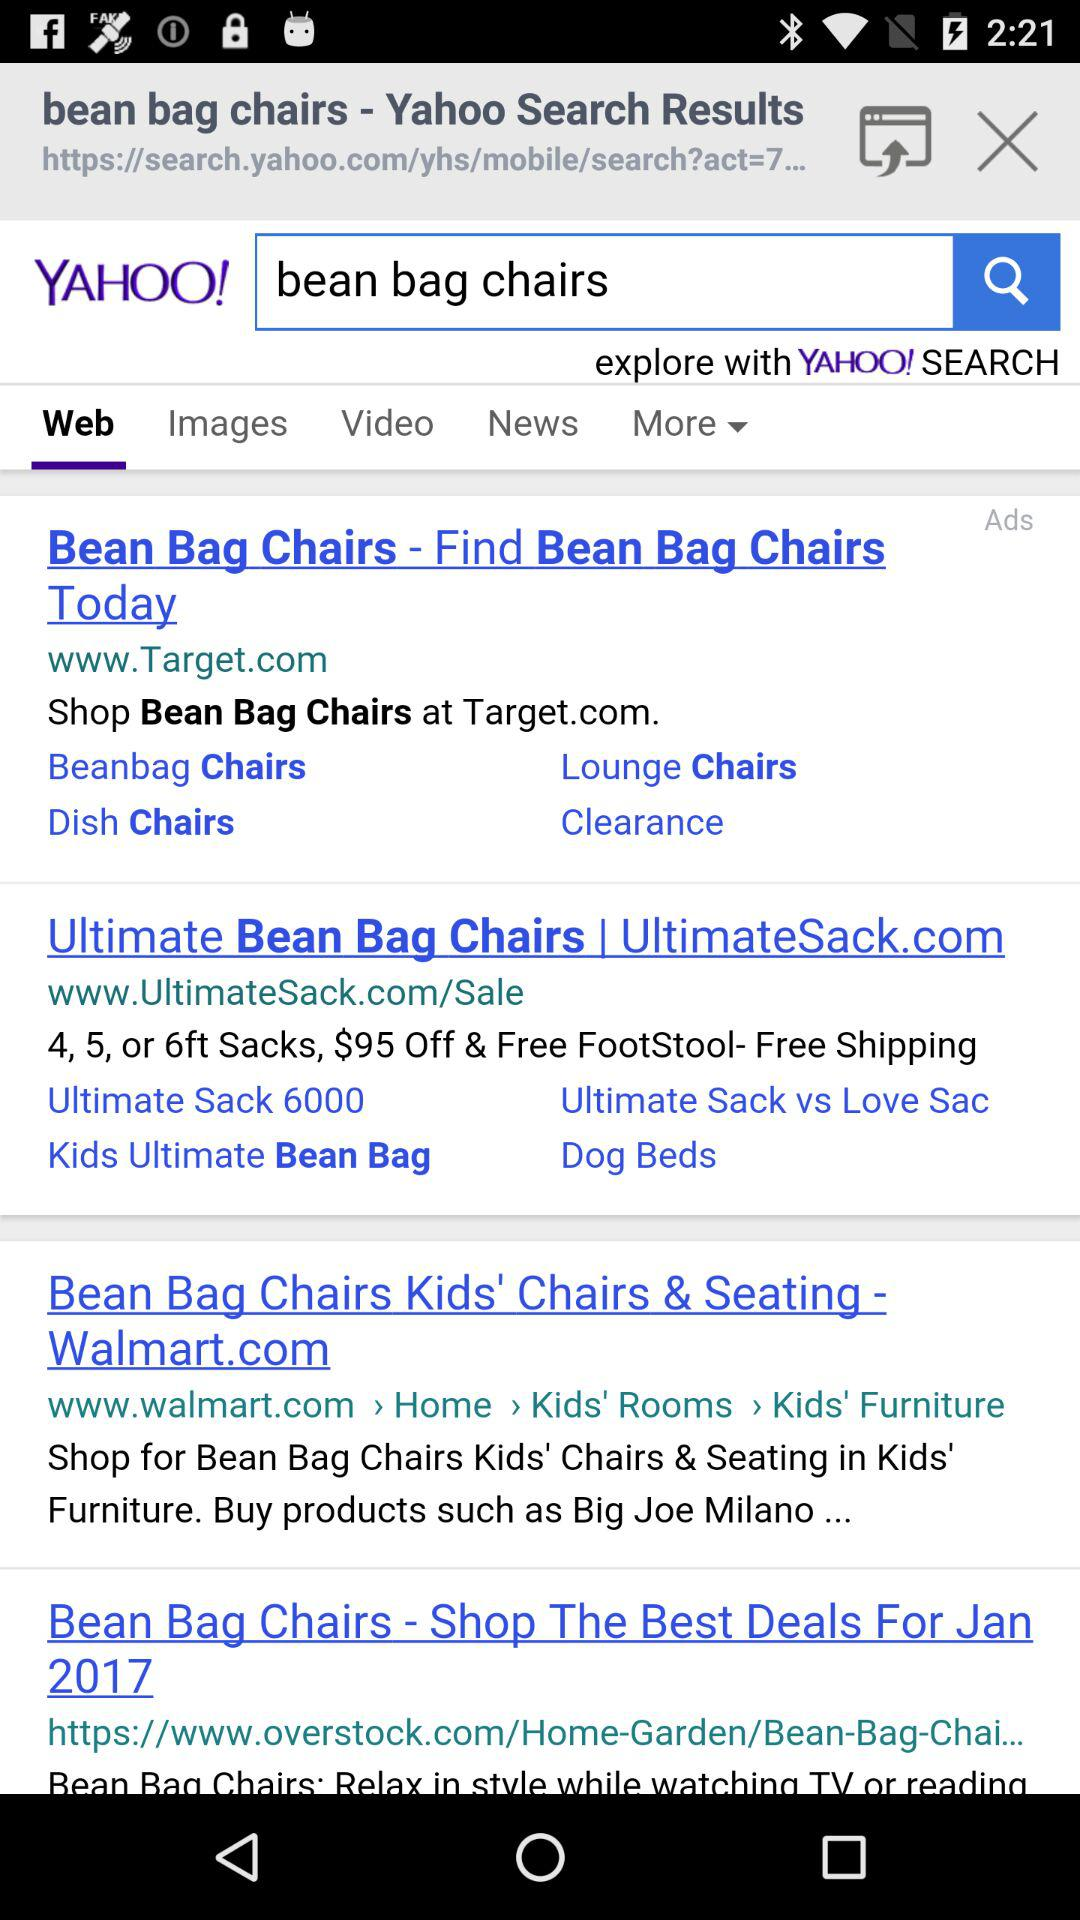Which tab is selected? The selected tab is "Web". 